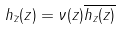Convert formula to latex. <formula><loc_0><loc_0><loc_500><loc_500>h _ { \bar { z } } ( z ) = \nu ( z ) \overline { h _ { z } ( z ) }</formula> 